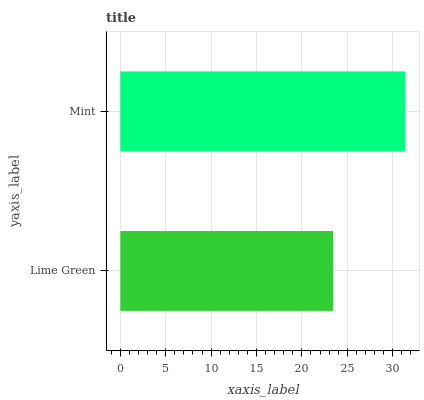Is Lime Green the minimum?
Answer yes or no. Yes. Is Mint the maximum?
Answer yes or no. Yes. Is Mint the minimum?
Answer yes or no. No. Is Mint greater than Lime Green?
Answer yes or no. Yes. Is Lime Green less than Mint?
Answer yes or no. Yes. Is Lime Green greater than Mint?
Answer yes or no. No. Is Mint less than Lime Green?
Answer yes or no. No. Is Mint the high median?
Answer yes or no. Yes. Is Lime Green the low median?
Answer yes or no. Yes. Is Lime Green the high median?
Answer yes or no. No. Is Mint the low median?
Answer yes or no. No. 